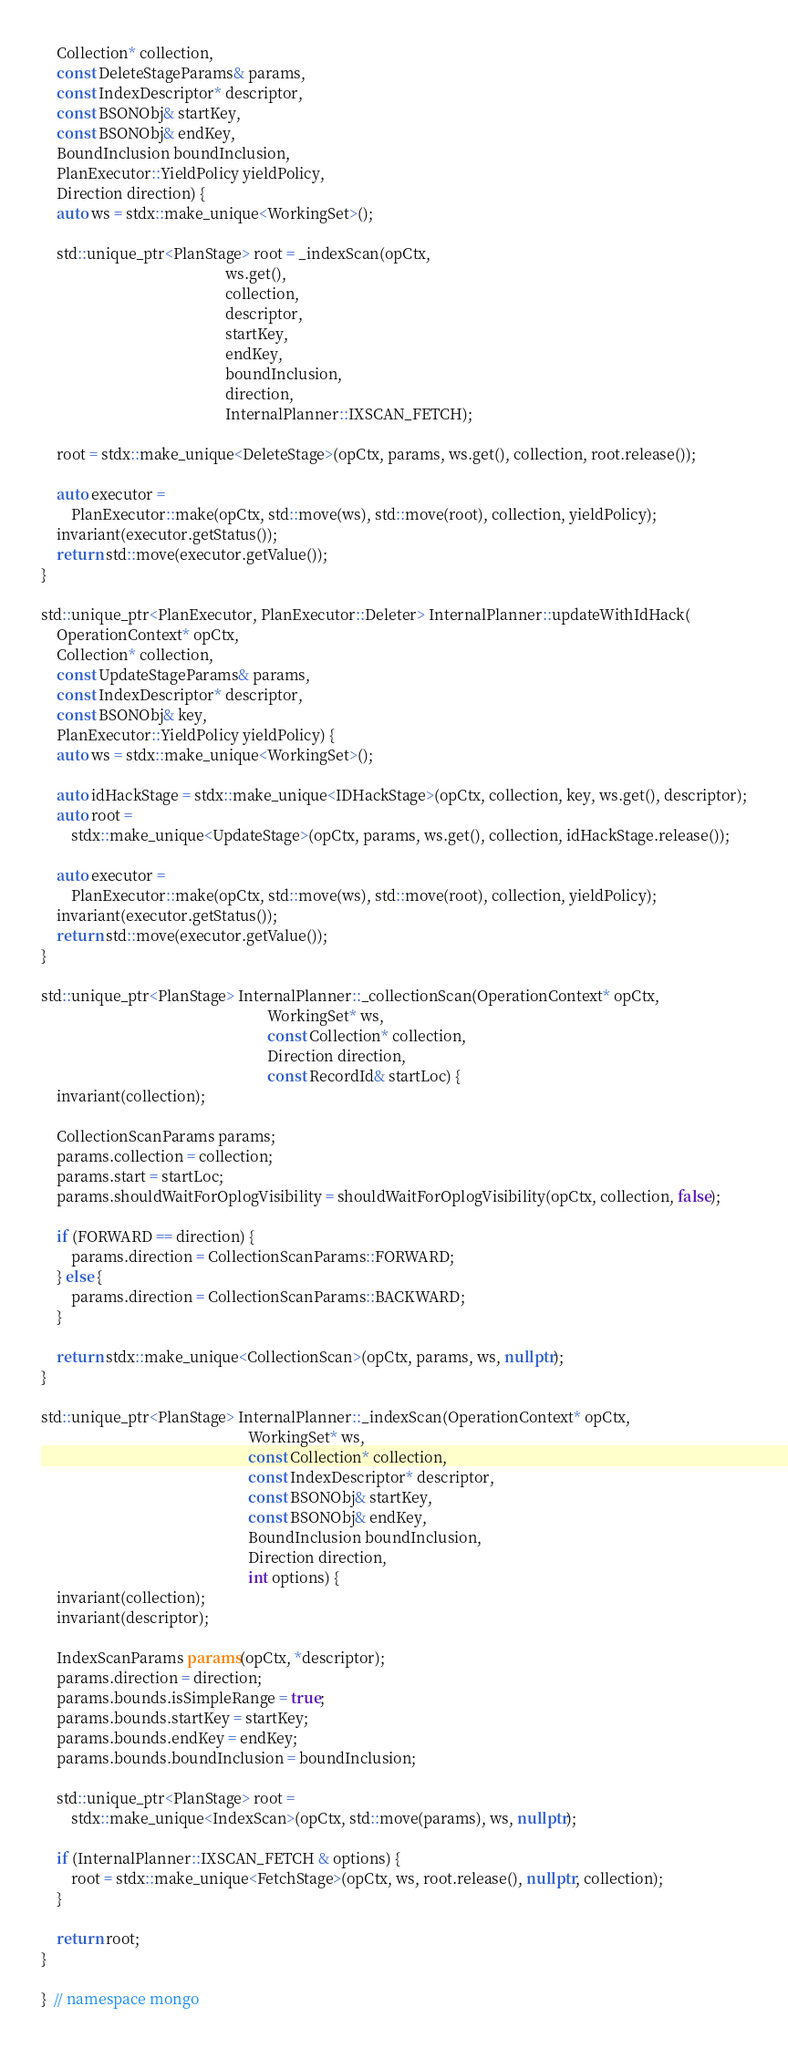<code> <loc_0><loc_0><loc_500><loc_500><_C++_>    Collection* collection,
    const DeleteStageParams& params,
    const IndexDescriptor* descriptor,
    const BSONObj& startKey,
    const BSONObj& endKey,
    BoundInclusion boundInclusion,
    PlanExecutor::YieldPolicy yieldPolicy,
    Direction direction) {
    auto ws = stdx::make_unique<WorkingSet>();

    std::unique_ptr<PlanStage> root = _indexScan(opCtx,
                                                 ws.get(),
                                                 collection,
                                                 descriptor,
                                                 startKey,
                                                 endKey,
                                                 boundInclusion,
                                                 direction,
                                                 InternalPlanner::IXSCAN_FETCH);

    root = stdx::make_unique<DeleteStage>(opCtx, params, ws.get(), collection, root.release());

    auto executor =
        PlanExecutor::make(opCtx, std::move(ws), std::move(root), collection, yieldPolicy);
    invariant(executor.getStatus());
    return std::move(executor.getValue());
}

std::unique_ptr<PlanExecutor, PlanExecutor::Deleter> InternalPlanner::updateWithIdHack(
    OperationContext* opCtx,
    Collection* collection,
    const UpdateStageParams& params,
    const IndexDescriptor* descriptor,
    const BSONObj& key,
    PlanExecutor::YieldPolicy yieldPolicy) {
    auto ws = stdx::make_unique<WorkingSet>();

    auto idHackStage = stdx::make_unique<IDHackStage>(opCtx, collection, key, ws.get(), descriptor);
    auto root =
        stdx::make_unique<UpdateStage>(opCtx, params, ws.get(), collection, idHackStage.release());

    auto executor =
        PlanExecutor::make(opCtx, std::move(ws), std::move(root), collection, yieldPolicy);
    invariant(executor.getStatus());
    return std::move(executor.getValue());
}

std::unique_ptr<PlanStage> InternalPlanner::_collectionScan(OperationContext* opCtx,
                                                            WorkingSet* ws,
                                                            const Collection* collection,
                                                            Direction direction,
                                                            const RecordId& startLoc) {
    invariant(collection);

    CollectionScanParams params;
    params.collection = collection;
    params.start = startLoc;
    params.shouldWaitForOplogVisibility = shouldWaitForOplogVisibility(opCtx, collection, false);

    if (FORWARD == direction) {
        params.direction = CollectionScanParams::FORWARD;
    } else {
        params.direction = CollectionScanParams::BACKWARD;
    }

    return stdx::make_unique<CollectionScan>(opCtx, params, ws, nullptr);
}

std::unique_ptr<PlanStage> InternalPlanner::_indexScan(OperationContext* opCtx,
                                                       WorkingSet* ws,
                                                       const Collection* collection,
                                                       const IndexDescriptor* descriptor,
                                                       const BSONObj& startKey,
                                                       const BSONObj& endKey,
                                                       BoundInclusion boundInclusion,
                                                       Direction direction,
                                                       int options) {
    invariant(collection);
    invariant(descriptor);

    IndexScanParams params(opCtx, *descriptor);
    params.direction = direction;
    params.bounds.isSimpleRange = true;
    params.bounds.startKey = startKey;
    params.bounds.endKey = endKey;
    params.bounds.boundInclusion = boundInclusion;

    std::unique_ptr<PlanStage> root =
        stdx::make_unique<IndexScan>(opCtx, std::move(params), ws, nullptr);

    if (InternalPlanner::IXSCAN_FETCH & options) {
        root = stdx::make_unique<FetchStage>(opCtx, ws, root.release(), nullptr, collection);
    }

    return root;
}

}  // namespace mongo
</code> 